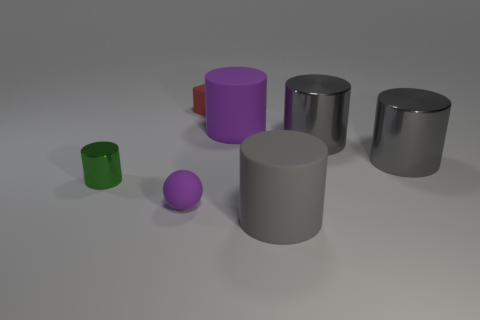Subtract all large cylinders. How many cylinders are left? 1 Subtract all purple spheres. How many gray cylinders are left? 3 Subtract all purple cylinders. How many cylinders are left? 4 Add 1 gray shiny objects. How many objects exist? 8 Subtract all red cylinders. Subtract all red balls. How many cylinders are left? 5 Subtract 0 green cubes. How many objects are left? 7 Subtract all cubes. How many objects are left? 6 Subtract all matte cylinders. Subtract all large metallic objects. How many objects are left? 3 Add 7 green cylinders. How many green cylinders are left? 8 Add 3 green cylinders. How many green cylinders exist? 4 